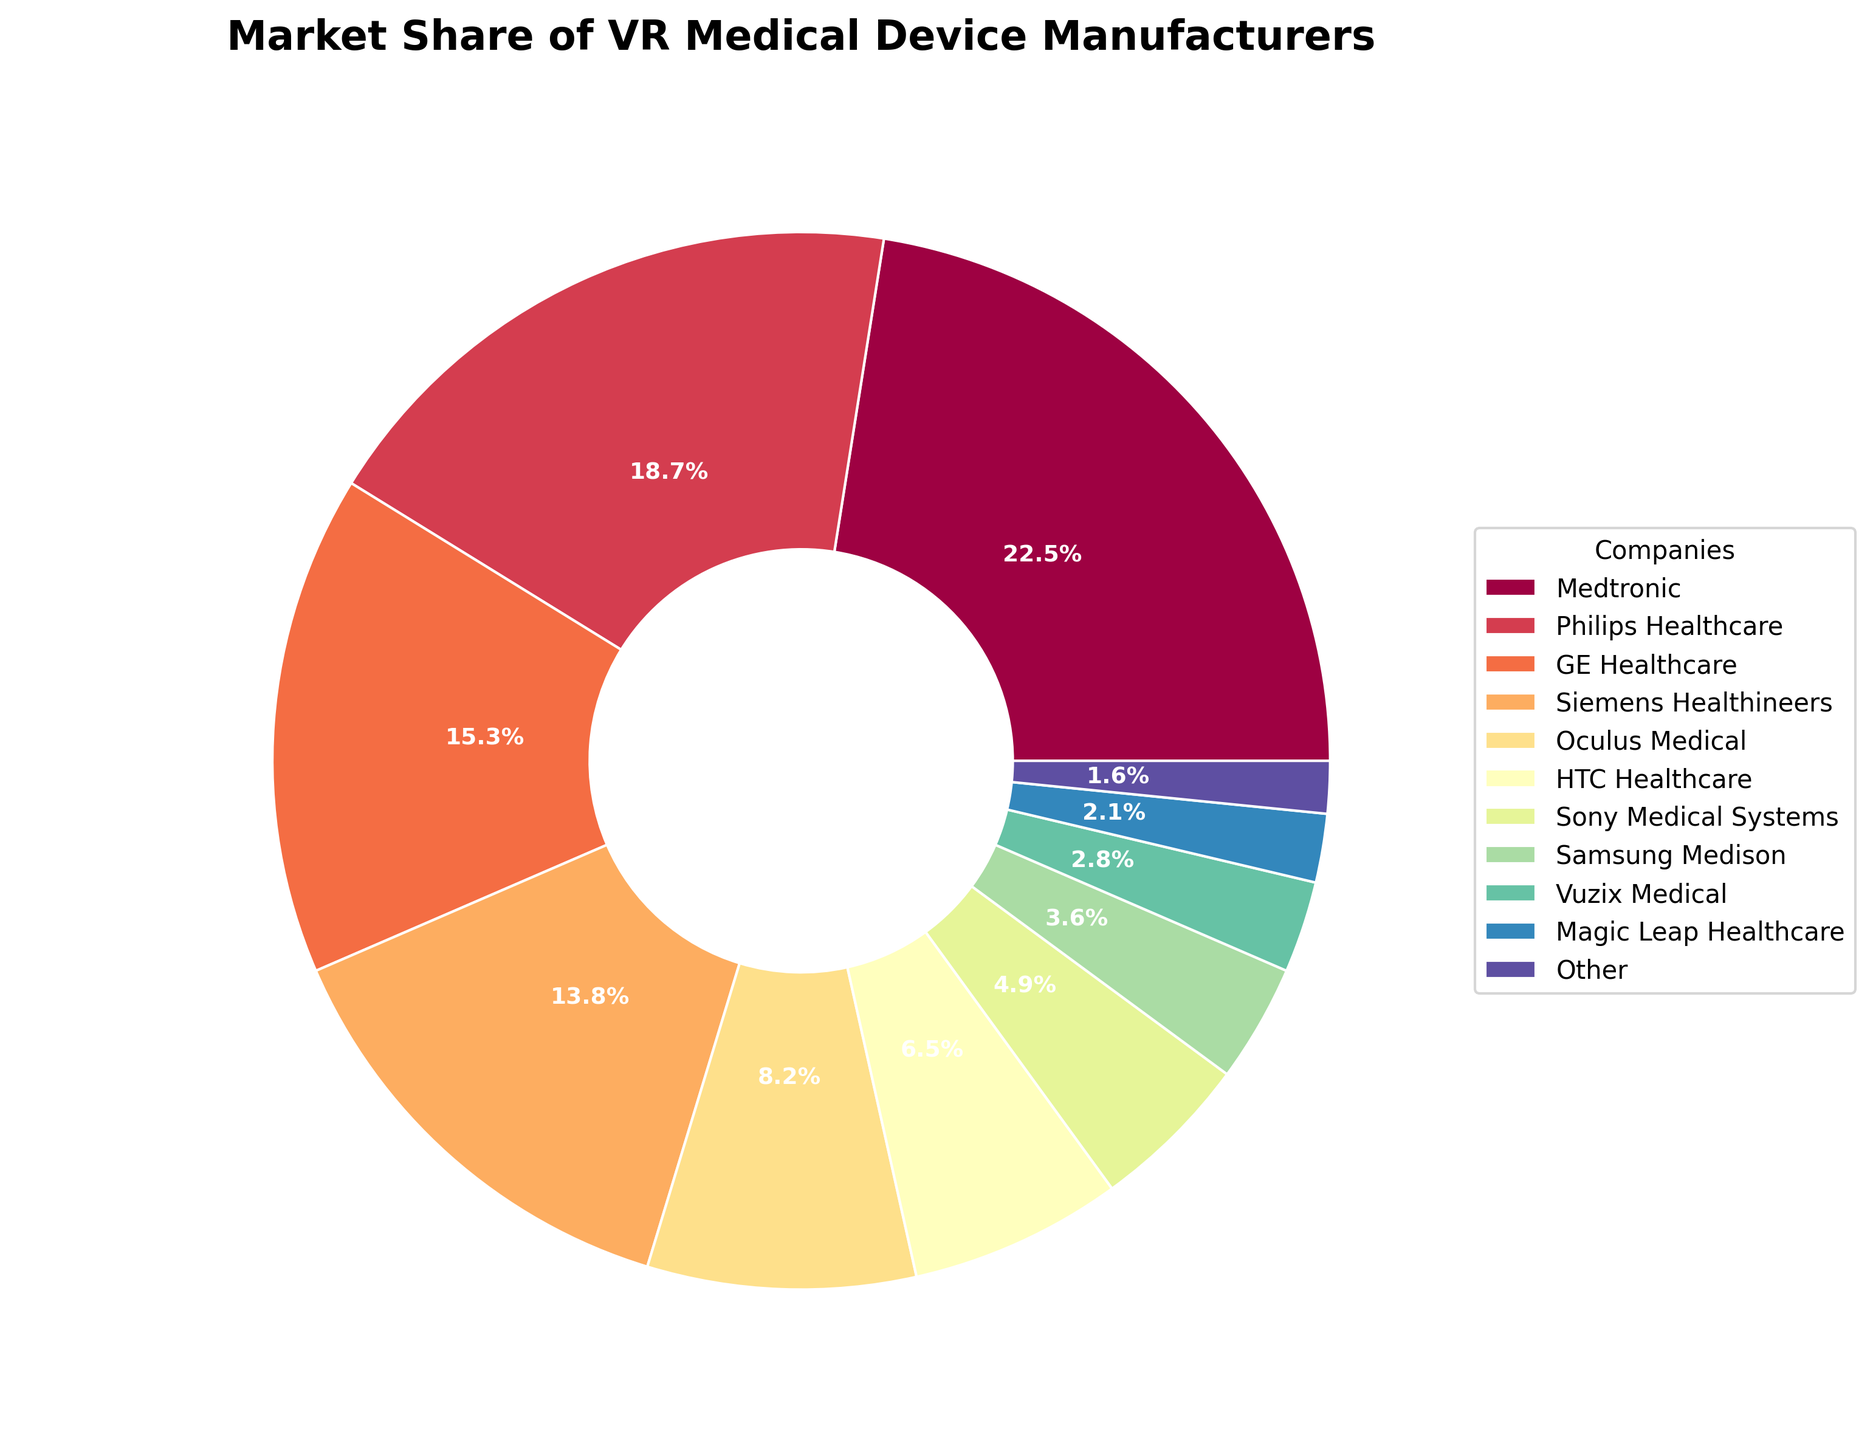What's the combined market share of Medtronic and Philips Healthcare? Add the market shares of Medtronic (22.5%) and Philips Healthcare (18.7%): \(22.5 + 18.7 = 41.2\).
Answer: 41.2% Which company has a larger market share, HTC Healthcare or Sony Medical Systems? Compare the market shares of HTC Healthcare (6.5%) and Sony Medical Systems (4.9%). HTC Healthcare has a larger share.
Answer: HTC Healthcare What is the market share difference between GE Healthcare and Siemens Healthineers? Subtract Siemens Healthineers' market share (13.8%) from GE Healthcare's share (15.3%): \(15.3 - 13.8 = 1.5\).
Answer: 1.5% Which company has the smallest market share and what is that share? Identify the company with the smallest market share, which is Magic Leap Healthcare at 2.1%.
Answer: Magic Leap Healthcare (2.1%) What's the total market share of the companies that have less than 5% each? Sum up the market shares of Sony Medical Systems (4.9%), Samsung Medison (3.6%), Vuzix Medical (2.8%), Magic Leap Healthcare (2.1%), and Other (1.6%): \(4.9 + 3.6 + 2.8 + 2.1 + 1.6 = 15\).
Answer: 15% How many companies have a market share greater than 10%? Count the companies with market shares greater than 10%: Medtronic (22.5%), Philips Healthcare (18.7%), GE Healthcare (15.3%), Siemens Healthineers (13.8%) make up 4 companies.
Answer: 4 What color represents Medtronic in the pie chart? Identify the segment color corresponding to Medtronic's label (Note: View the chart to see the actual color, typically first in a qualitative colormap like Spectral).
Answer: (Based on the viewer's identification) Is the combined market share of Oculus Medical and HTC Healthcare greater than that of Siemens Healthineers? Sum the market shares of Oculus Medical (8.2%) and HTC Healthcare (6.5%): \(8.2 + 6.5 = 14.7\), which is greater than Siemens Healthineers' 13.8%.
Answer: Yes Which company has a market share closest to 20%? Identify the company whose market share is closest to 20%, which is Philips Healthcare with 18.7%.
Answer: Philips Healthcare What total market share is represented by the top three companies? Add the market shares of the top three companies: Medtronic (22.5%), Philips Healthcare (18.7%), and GE Healthcare (15.3%): \(22.5 + 18.7 + 15.3 = 56.5\).
Answer: 56.5% 